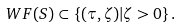<formula> <loc_0><loc_0><loc_500><loc_500>\ W F ( S ) \subset \{ ( \tau , \zeta ) | \zeta > 0 \} \, .</formula> 